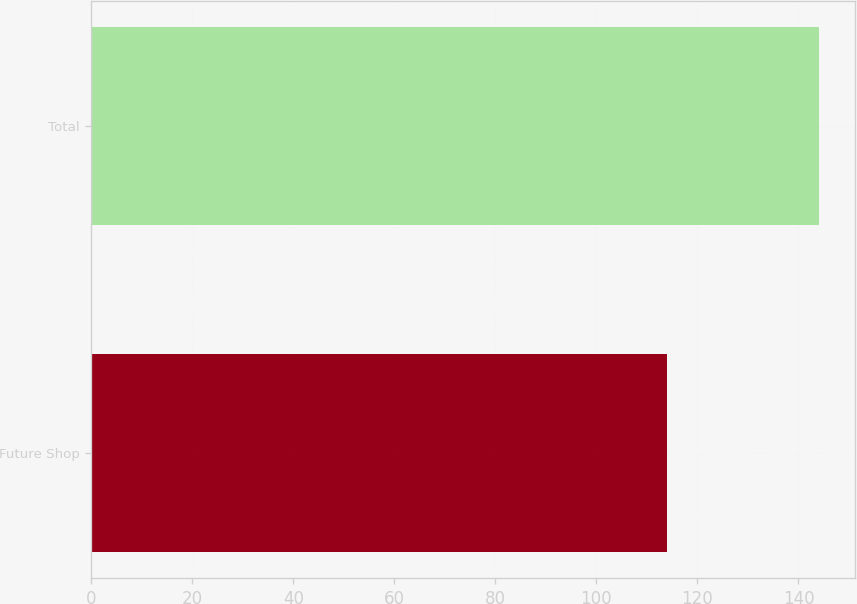Convert chart to OTSL. <chart><loc_0><loc_0><loc_500><loc_500><bar_chart><fcel>Future Shop<fcel>Total<nl><fcel>114<fcel>144<nl></chart> 